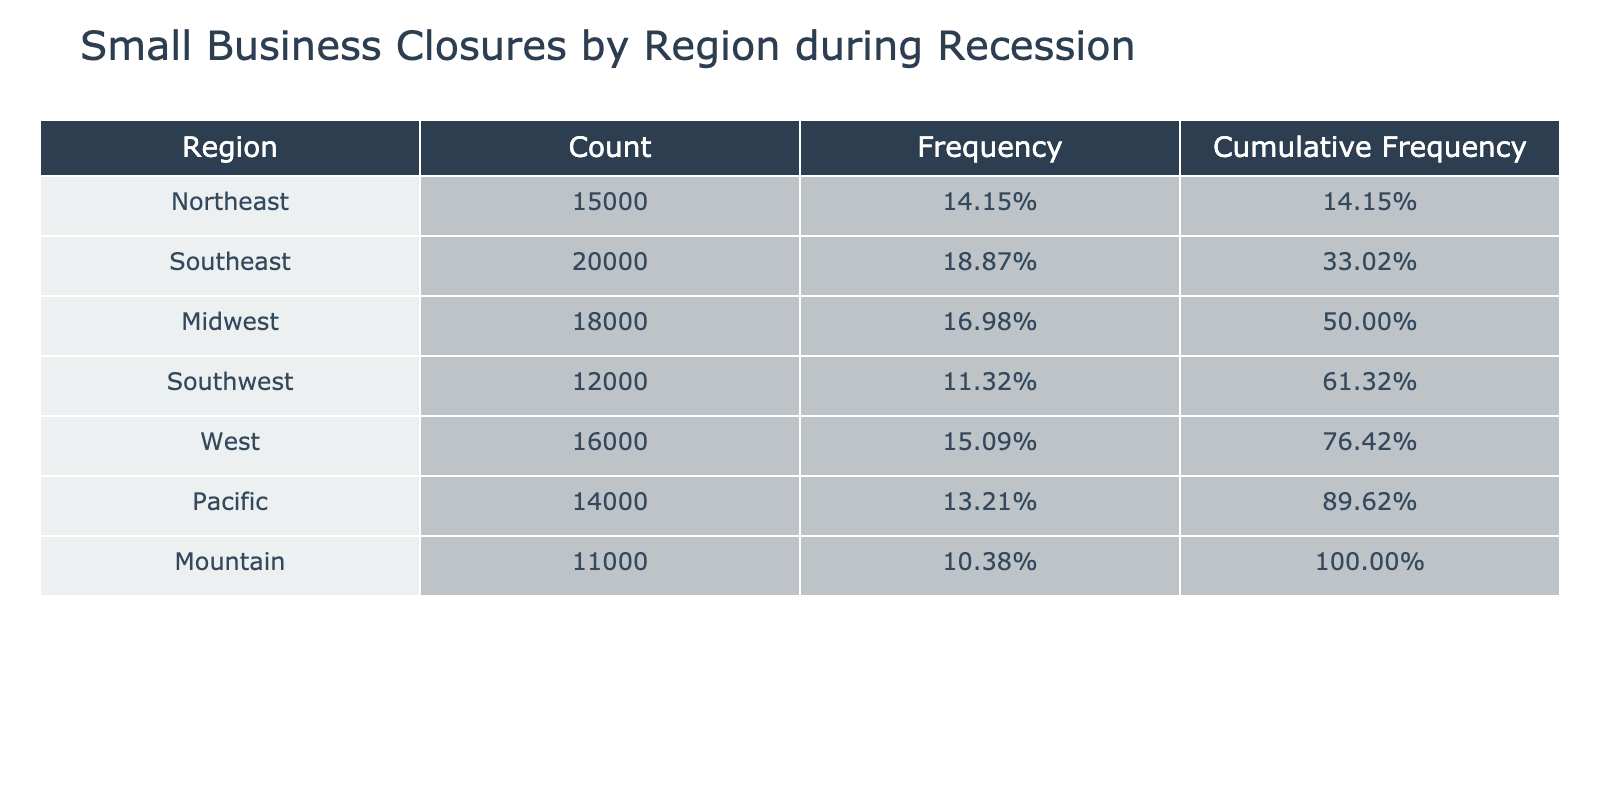What region had the highest count of small business closures? By examining the 'Count of Small Business Closures' column, we see that the Southeast region has the highest number at 20000 closures.
Answer: Southeast What is the total count of small business closures across all regions? To find the total, we sum the counts from each region: 15000 + 20000 + 18000 + 12000 + 16000 + 14000 + 11000 = 106000.
Answer: 106000 Is the count of small business closures in the Pacific region greater than that in the Midwest region? The count for the Pacific region is 14000, while the Midwest region has 18000. Since 14000 is less than 18000, the statement is false.
Answer: No What percentage of total small business closures does the Southwest region represent? The count for the Southwest region is 12000. To find the percentage, we divide by the total: (12000 / 106000) * 100 = approximately 11.32%.
Answer: 11.32% Which region experienced fewer closures: Mountain or Northeast? The Mountain region had 11000 closures, and the Northeast had 15000 closures. Since 11000 is less than 15000, the Mountain region experienced fewer closures.
Answer: Mountain What is the cumulative frequency for the Midwest region? We calculate the cumulative frequency by summing the frequencies from regions listed before the Midwest. The Midwest is the third region listed, so we add the frequencies of Northeast (15000), Southeast (20000), and Midwest (18000). The intermediate values are (15000/106000) + (20000/106000) + (18000/106000) = approximately 0.55, or 55%.
Answer: 55% How many more closures were there in the Northeast compared to the Mountain region? The Northeast had 15000 closures, while the Mountain region had 11000 closures. The difference is 15000 - 11000 = 4000.
Answer: 4000 What regions had closure counts below the average? The average count is calculated as total closures divided by the number of regions: 106000 / 7 = 15142.86. The regions with counts below this average are Southwest (12000), Mountain (11000), and Pacific (14000).
Answer: Southwest, Mountain, Pacific Was the number of closures in the West region higher than the total for the Mountain and Southwest regions combined? The West region had 16000 closures. The Mountain and Southwest regions combined had 11000 + 12000 = 23000. Since 16000 is less than 23000, the statement is false.
Answer: No 